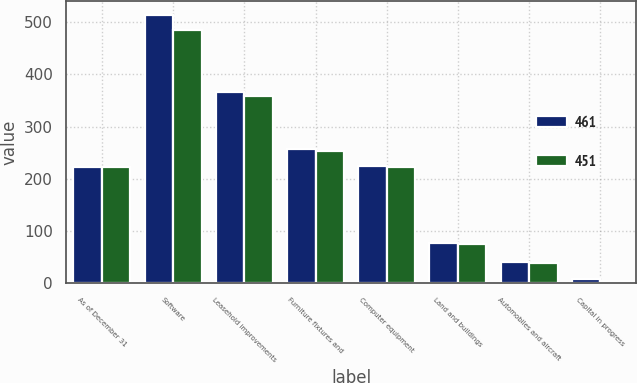Convert chart. <chart><loc_0><loc_0><loc_500><loc_500><stacked_bar_chart><ecel><fcel>As of December 31<fcel>Software<fcel>Leasehold improvements<fcel>Furniture fixtures and<fcel>Computer equipment<fcel>Land and buildings<fcel>Automobiles and aircraft<fcel>Capital in progress<nl><fcel>461<fcel>223.5<fcel>514<fcel>366<fcel>258<fcel>225<fcel>78<fcel>40<fcel>8<nl><fcel>451<fcel>223.5<fcel>485<fcel>358<fcel>254<fcel>222<fcel>76<fcel>39<fcel>4<nl></chart> 